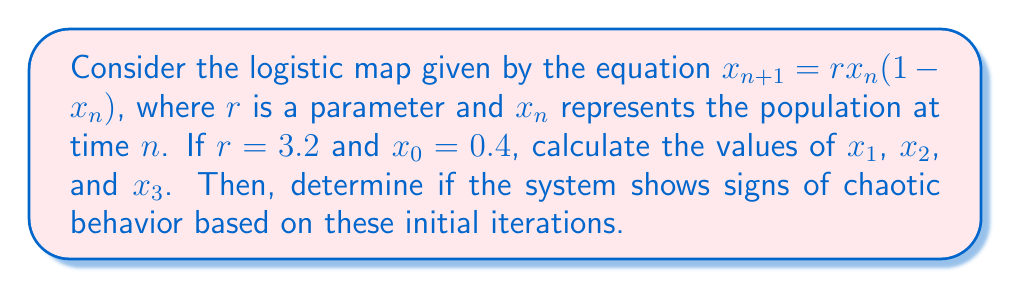Can you answer this question? Let's approach this step-by-step:

1) The logistic map is given by $x_{n+1} = rx_n(1-x_n)$ with $r = 3.2$ and $x_0 = 0.4$

2) To find $x_1$:
   $x_1 = 3.2 \cdot 0.4 \cdot (1-0.4)$
   $x_1 = 3.2 \cdot 0.4 \cdot 0.6$
   $x_1 = 0.768$

3) To find $x_2$:
   $x_2 = 3.2 \cdot 0.768 \cdot (1-0.768)$
   $x_2 = 3.2 \cdot 0.768 \cdot 0.232$
   $x_2 \approx 0.570$

4) To find $x_3$:
   $x_3 = 3.2 \cdot 0.570 \cdot (1-0.570)$
   $x_3 = 3.2 \cdot 0.570 \cdot 0.430$
   $x_3 \approx 0.784$

5) To determine if the system shows signs of chaotic behavior, we need to observe if there's a pattern in these initial iterations.

   $x_0 = 0.4$
   $x_1 \approx 0.768$
   $x_2 \approx 0.570$
   $x_3 \approx 0.784$

   We can see that the values are not converging to a single point or oscillating between two points. Instead, they seem to be jumping around unpredictably. This is an early indication of potential chaotic behavior.

6) However, to truly confirm chaotic behavior, we would need to calculate more iterations and analyze the long-term behavior of the system. Chaotic systems are characterized by their sensitivity to initial conditions and their long-term unpredictability.
Answer: $x_1 \approx 0.768$, $x_2 \approx 0.570$, $x_3 \approx 0.784$. Initial iterations suggest potential chaotic behavior, but more iterations are needed for confirmation. 